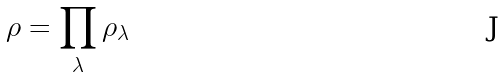Convert formula to latex. <formula><loc_0><loc_0><loc_500><loc_500>\rho = \prod _ { \lambda } \rho _ { \lambda }</formula> 